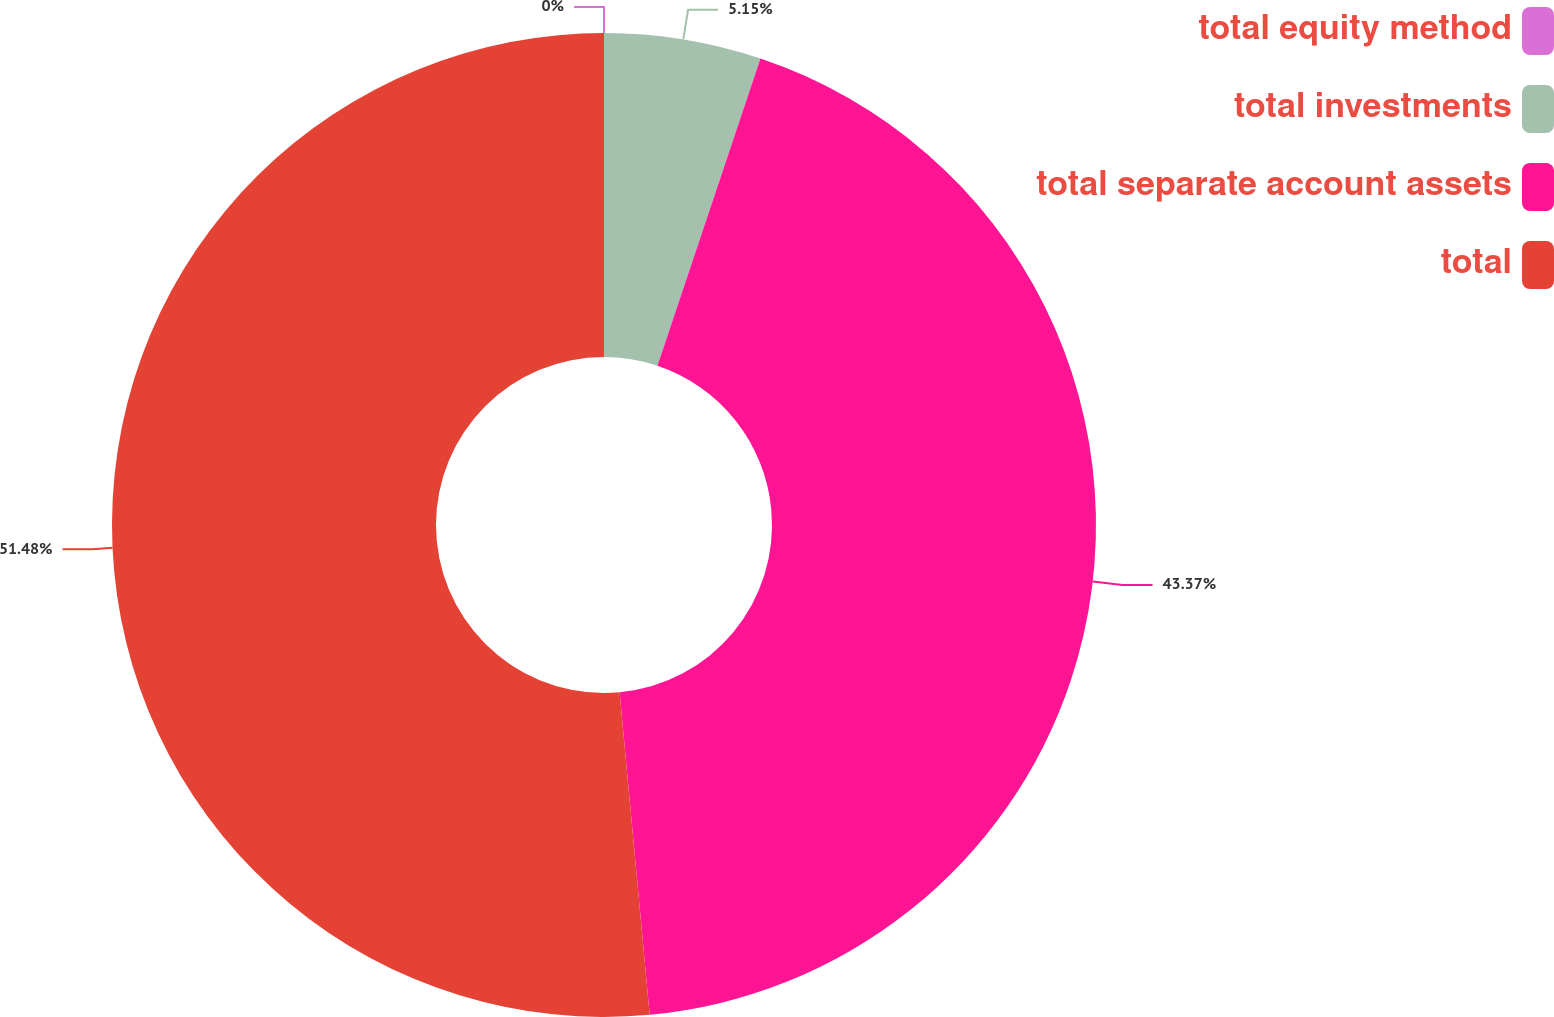<chart> <loc_0><loc_0><loc_500><loc_500><pie_chart><fcel>total equity method<fcel>total investments<fcel>total separate account assets<fcel>total<nl><fcel>0.0%<fcel>5.15%<fcel>43.37%<fcel>51.48%<nl></chart> 